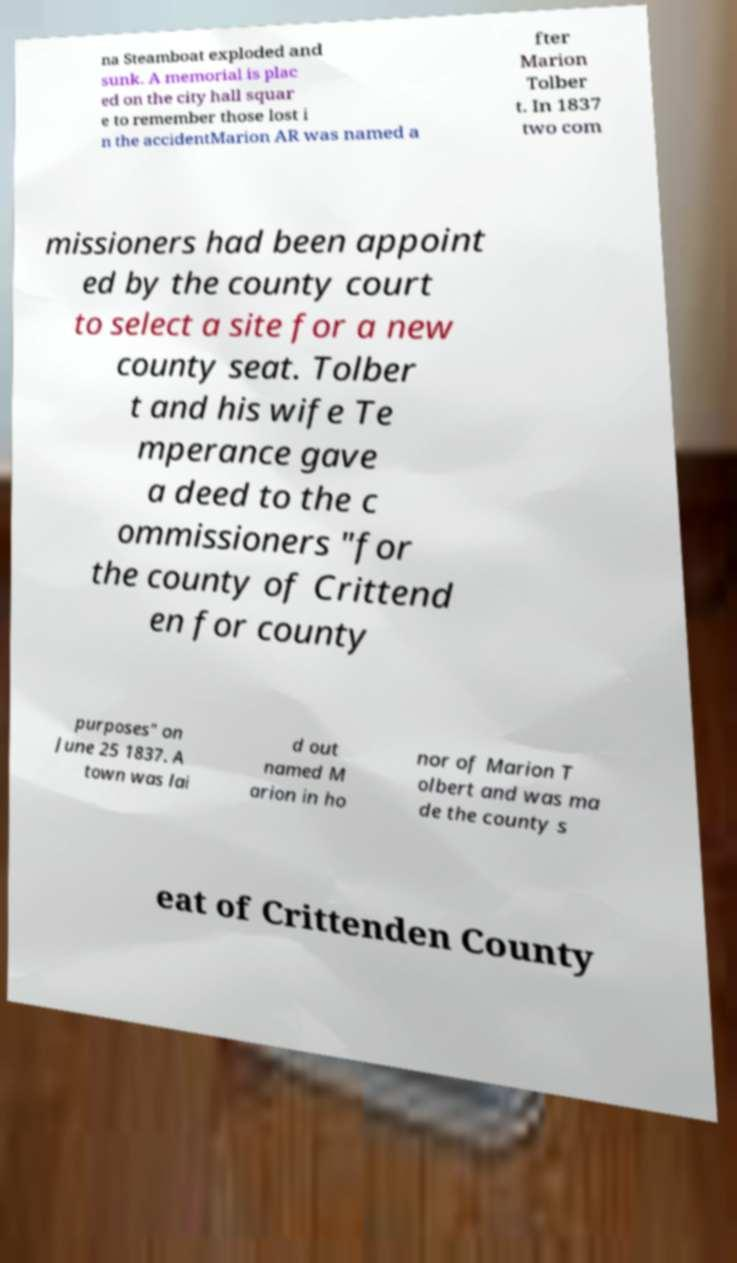Could you extract and type out the text from this image? na Steamboat exploded and sunk. A memorial is plac ed on the city hall squar e to remember those lost i n the accidentMarion AR was named a fter Marion Tolber t. In 1837 two com missioners had been appoint ed by the county court to select a site for a new county seat. Tolber t and his wife Te mperance gave a deed to the c ommissioners "for the county of Crittend en for county purposes" on June 25 1837. A town was lai d out named M arion in ho nor of Marion T olbert and was ma de the county s eat of Crittenden County 